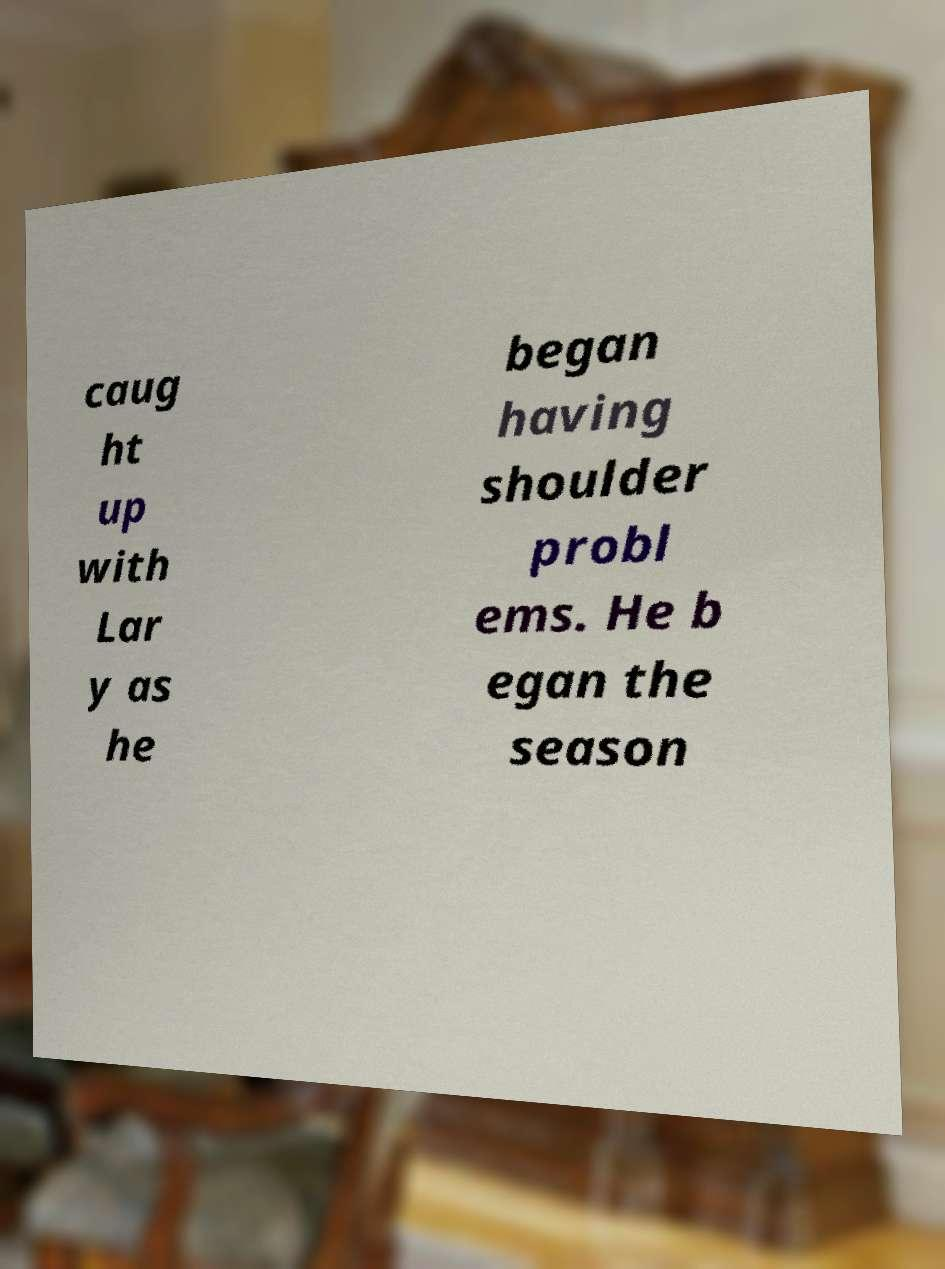Can you accurately transcribe the text from the provided image for me? caug ht up with Lar y as he began having shoulder probl ems. He b egan the season 